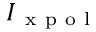<formula> <loc_0><loc_0><loc_500><loc_500>I _ { x p o l }</formula> 